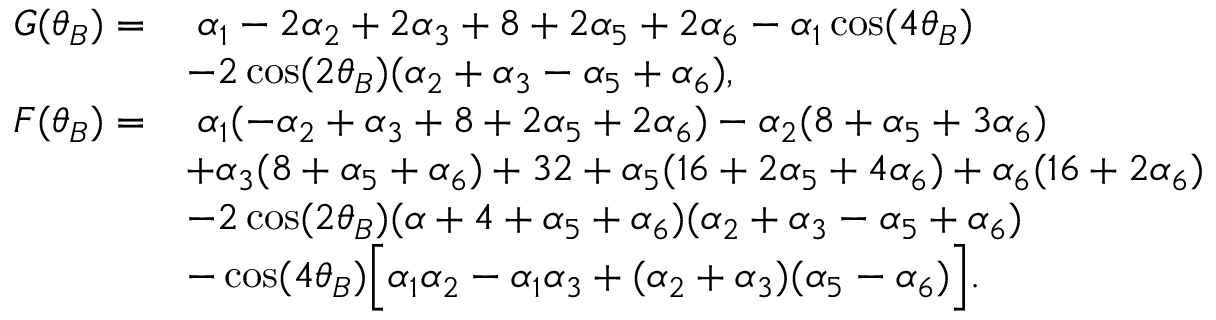<formula> <loc_0><loc_0><loc_500><loc_500>\begin{array} { r l } { G ( \theta _ { B } ) = } & { \, \alpha _ { 1 } - 2 \alpha _ { 2 } + 2 \alpha _ { 3 } + 8 + 2 \alpha _ { 5 } + 2 \alpha _ { 6 } - \alpha _ { 1 } \cos ( 4 \theta _ { B } ) } \\ & { - 2 \cos ( 2 \theta _ { B } ) ( \alpha _ { 2 } + \alpha _ { 3 } - \alpha _ { 5 } + \alpha _ { 6 } ) , } \\ { F ( \theta _ { B } ) = } & { \, \alpha _ { 1 } ( - \alpha _ { 2 } + \alpha _ { 3 } + 8 + 2 \alpha _ { 5 } + 2 \alpha _ { 6 } ) - \alpha _ { 2 } ( 8 + \alpha _ { 5 } + 3 \alpha _ { 6 } ) } \\ & { + \alpha _ { 3 } ( 8 + \alpha _ { 5 } + \alpha _ { 6 } ) + 3 2 + \alpha _ { 5 } ( 1 6 + 2 \alpha _ { 5 } + 4 \alpha _ { 6 } ) + \alpha _ { 6 } ( 1 6 + 2 \alpha _ { 6 } ) } \\ & { - 2 \cos ( 2 \theta _ { B } ) ( \alpha + 4 + \alpha _ { 5 } + \alpha _ { 6 } ) ( \alpha _ { 2 } + \alpha _ { 3 } - \alpha _ { 5 } + \alpha _ { 6 } ) } \\ & { - \cos ( 4 \theta _ { B } ) \left [ \alpha _ { 1 } \alpha _ { 2 } - \alpha _ { 1 } \alpha _ { 3 } + ( \alpha _ { 2 } + \alpha _ { 3 } ) ( \alpha _ { 5 } - \alpha _ { 6 } ) \right ] . } \end{array}</formula> 